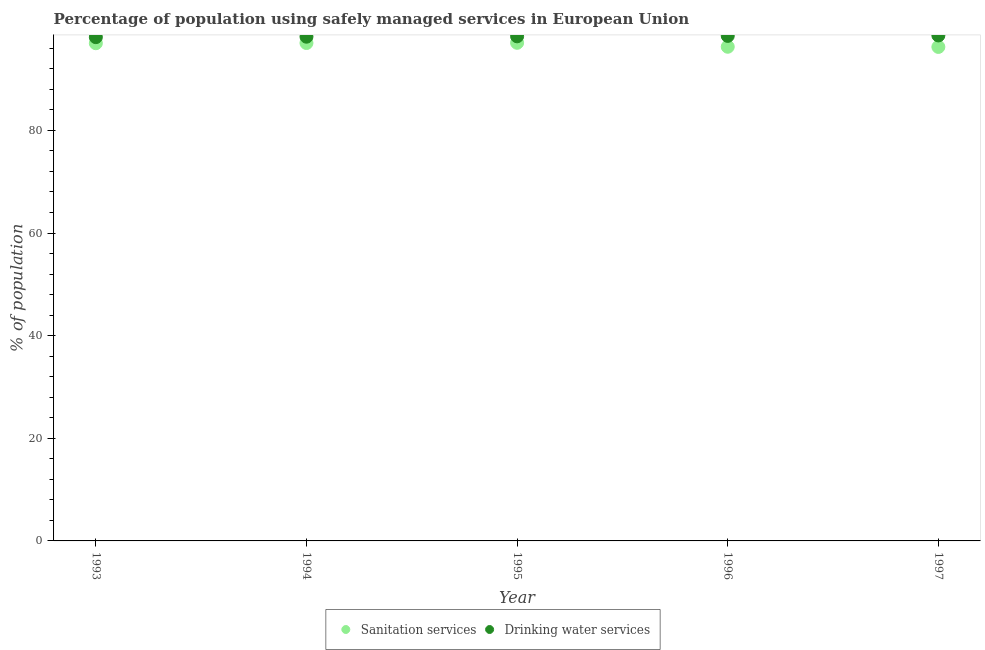Is the number of dotlines equal to the number of legend labels?
Your response must be concise. Yes. What is the percentage of population who used drinking water services in 1995?
Your answer should be very brief. 98.34. Across all years, what is the maximum percentage of population who used drinking water services?
Ensure brevity in your answer.  98.51. Across all years, what is the minimum percentage of population who used sanitation services?
Keep it short and to the point. 96.27. In which year was the percentage of population who used sanitation services minimum?
Give a very brief answer. 1997. What is the total percentage of population who used drinking water services in the graph?
Provide a succinct answer. 491.7. What is the difference between the percentage of population who used sanitation services in 1993 and that in 1995?
Provide a succinct answer. -0.08. What is the difference between the percentage of population who used drinking water services in 1997 and the percentage of population who used sanitation services in 1994?
Provide a short and direct response. 1.47. What is the average percentage of population who used drinking water services per year?
Your response must be concise. 98.34. In the year 1997, what is the difference between the percentage of population who used drinking water services and percentage of population who used sanitation services?
Your answer should be very brief. 2.24. What is the ratio of the percentage of population who used sanitation services in 1996 to that in 1997?
Give a very brief answer. 1. Is the percentage of population who used sanitation services in 1993 less than that in 1997?
Your answer should be compact. No. Is the difference between the percentage of population who used drinking water services in 1993 and 1996 greater than the difference between the percentage of population who used sanitation services in 1993 and 1996?
Your answer should be very brief. No. What is the difference between the highest and the second highest percentage of population who used sanitation services?
Your answer should be very brief. 0.04. What is the difference between the highest and the lowest percentage of population who used sanitation services?
Give a very brief answer. 0.81. In how many years, is the percentage of population who used sanitation services greater than the average percentage of population who used sanitation services taken over all years?
Provide a succinct answer. 3. Is the sum of the percentage of population who used sanitation services in 1993 and 1997 greater than the maximum percentage of population who used drinking water services across all years?
Provide a succinct answer. Yes. Are the values on the major ticks of Y-axis written in scientific E-notation?
Provide a short and direct response. No. What is the title of the graph?
Provide a short and direct response. Percentage of population using safely managed services in European Union. What is the label or title of the X-axis?
Your answer should be compact. Year. What is the label or title of the Y-axis?
Provide a succinct answer. % of population. What is the % of population of Sanitation services in 1993?
Your answer should be compact. 96.99. What is the % of population in Drinking water services in 1993?
Provide a short and direct response. 98.17. What is the % of population in Sanitation services in 1994?
Your answer should be compact. 97.03. What is the % of population in Drinking water services in 1994?
Your response must be concise. 98.26. What is the % of population in Sanitation services in 1995?
Offer a very short reply. 97.08. What is the % of population in Drinking water services in 1995?
Offer a very short reply. 98.34. What is the % of population of Sanitation services in 1996?
Keep it short and to the point. 96.3. What is the % of population of Drinking water services in 1996?
Provide a succinct answer. 98.42. What is the % of population in Sanitation services in 1997?
Ensure brevity in your answer.  96.27. What is the % of population of Drinking water services in 1997?
Keep it short and to the point. 98.51. Across all years, what is the maximum % of population in Sanitation services?
Ensure brevity in your answer.  97.08. Across all years, what is the maximum % of population of Drinking water services?
Ensure brevity in your answer.  98.51. Across all years, what is the minimum % of population of Sanitation services?
Your answer should be compact. 96.27. Across all years, what is the minimum % of population in Drinking water services?
Your response must be concise. 98.17. What is the total % of population in Sanitation services in the graph?
Provide a succinct answer. 483.67. What is the total % of population of Drinking water services in the graph?
Give a very brief answer. 491.7. What is the difference between the % of population of Sanitation services in 1993 and that in 1994?
Your answer should be compact. -0.04. What is the difference between the % of population of Drinking water services in 1993 and that in 1994?
Your answer should be compact. -0.09. What is the difference between the % of population of Sanitation services in 1993 and that in 1995?
Your answer should be compact. -0.08. What is the difference between the % of population in Drinking water services in 1993 and that in 1995?
Provide a succinct answer. -0.16. What is the difference between the % of population of Sanitation services in 1993 and that in 1996?
Ensure brevity in your answer.  0.69. What is the difference between the % of population in Drinking water services in 1993 and that in 1996?
Make the answer very short. -0.24. What is the difference between the % of population of Sanitation services in 1993 and that in 1997?
Provide a succinct answer. 0.72. What is the difference between the % of population in Drinking water services in 1993 and that in 1997?
Offer a terse response. -0.33. What is the difference between the % of population of Sanitation services in 1994 and that in 1995?
Your answer should be compact. -0.04. What is the difference between the % of population of Drinking water services in 1994 and that in 1995?
Make the answer very short. -0.07. What is the difference between the % of population in Sanitation services in 1994 and that in 1996?
Make the answer very short. 0.73. What is the difference between the % of population in Drinking water services in 1994 and that in 1996?
Your answer should be very brief. -0.16. What is the difference between the % of population of Sanitation services in 1994 and that in 1997?
Provide a succinct answer. 0.76. What is the difference between the % of population in Drinking water services in 1994 and that in 1997?
Offer a terse response. -0.24. What is the difference between the % of population in Sanitation services in 1995 and that in 1996?
Give a very brief answer. 0.77. What is the difference between the % of population in Drinking water services in 1995 and that in 1996?
Give a very brief answer. -0.08. What is the difference between the % of population of Sanitation services in 1995 and that in 1997?
Offer a very short reply. 0.81. What is the difference between the % of population in Drinking water services in 1995 and that in 1997?
Give a very brief answer. -0.17. What is the difference between the % of population of Sanitation services in 1996 and that in 1997?
Provide a succinct answer. 0.03. What is the difference between the % of population of Drinking water services in 1996 and that in 1997?
Offer a very short reply. -0.09. What is the difference between the % of population in Sanitation services in 1993 and the % of population in Drinking water services in 1994?
Keep it short and to the point. -1.27. What is the difference between the % of population of Sanitation services in 1993 and the % of population of Drinking water services in 1995?
Ensure brevity in your answer.  -1.34. What is the difference between the % of population of Sanitation services in 1993 and the % of population of Drinking water services in 1996?
Offer a terse response. -1.43. What is the difference between the % of population of Sanitation services in 1993 and the % of population of Drinking water services in 1997?
Your answer should be compact. -1.52. What is the difference between the % of population of Sanitation services in 1994 and the % of population of Drinking water services in 1995?
Keep it short and to the point. -1.3. What is the difference between the % of population in Sanitation services in 1994 and the % of population in Drinking water services in 1996?
Provide a succinct answer. -1.39. What is the difference between the % of population in Sanitation services in 1994 and the % of population in Drinking water services in 1997?
Your answer should be very brief. -1.47. What is the difference between the % of population of Sanitation services in 1995 and the % of population of Drinking water services in 1996?
Offer a terse response. -1.34. What is the difference between the % of population of Sanitation services in 1995 and the % of population of Drinking water services in 1997?
Provide a succinct answer. -1.43. What is the difference between the % of population in Sanitation services in 1996 and the % of population in Drinking water services in 1997?
Give a very brief answer. -2.2. What is the average % of population of Sanitation services per year?
Offer a terse response. 96.73. What is the average % of population in Drinking water services per year?
Offer a terse response. 98.34. In the year 1993, what is the difference between the % of population of Sanitation services and % of population of Drinking water services?
Offer a terse response. -1.18. In the year 1994, what is the difference between the % of population of Sanitation services and % of population of Drinking water services?
Offer a very short reply. -1.23. In the year 1995, what is the difference between the % of population in Sanitation services and % of population in Drinking water services?
Keep it short and to the point. -1.26. In the year 1996, what is the difference between the % of population in Sanitation services and % of population in Drinking water services?
Make the answer very short. -2.12. In the year 1997, what is the difference between the % of population of Sanitation services and % of population of Drinking water services?
Provide a succinct answer. -2.24. What is the ratio of the % of population in Sanitation services in 1993 to that in 1996?
Offer a very short reply. 1.01. What is the ratio of the % of population of Drinking water services in 1993 to that in 1996?
Give a very brief answer. 1. What is the ratio of the % of population in Sanitation services in 1993 to that in 1997?
Ensure brevity in your answer.  1.01. What is the ratio of the % of population in Drinking water services in 1993 to that in 1997?
Your answer should be very brief. 1. What is the ratio of the % of population of Sanitation services in 1994 to that in 1995?
Your answer should be compact. 1. What is the ratio of the % of population of Drinking water services in 1994 to that in 1995?
Your answer should be compact. 1. What is the ratio of the % of population in Sanitation services in 1994 to that in 1996?
Give a very brief answer. 1.01. What is the ratio of the % of population of Sanitation services in 1994 to that in 1997?
Give a very brief answer. 1.01. What is the ratio of the % of population in Drinking water services in 1995 to that in 1996?
Make the answer very short. 1. What is the ratio of the % of population in Sanitation services in 1995 to that in 1997?
Keep it short and to the point. 1.01. What is the ratio of the % of population of Sanitation services in 1996 to that in 1997?
Your answer should be very brief. 1. What is the ratio of the % of population of Drinking water services in 1996 to that in 1997?
Ensure brevity in your answer.  1. What is the difference between the highest and the second highest % of population of Sanitation services?
Your answer should be very brief. 0.04. What is the difference between the highest and the second highest % of population of Drinking water services?
Give a very brief answer. 0.09. What is the difference between the highest and the lowest % of population in Sanitation services?
Your response must be concise. 0.81. What is the difference between the highest and the lowest % of population in Drinking water services?
Make the answer very short. 0.33. 